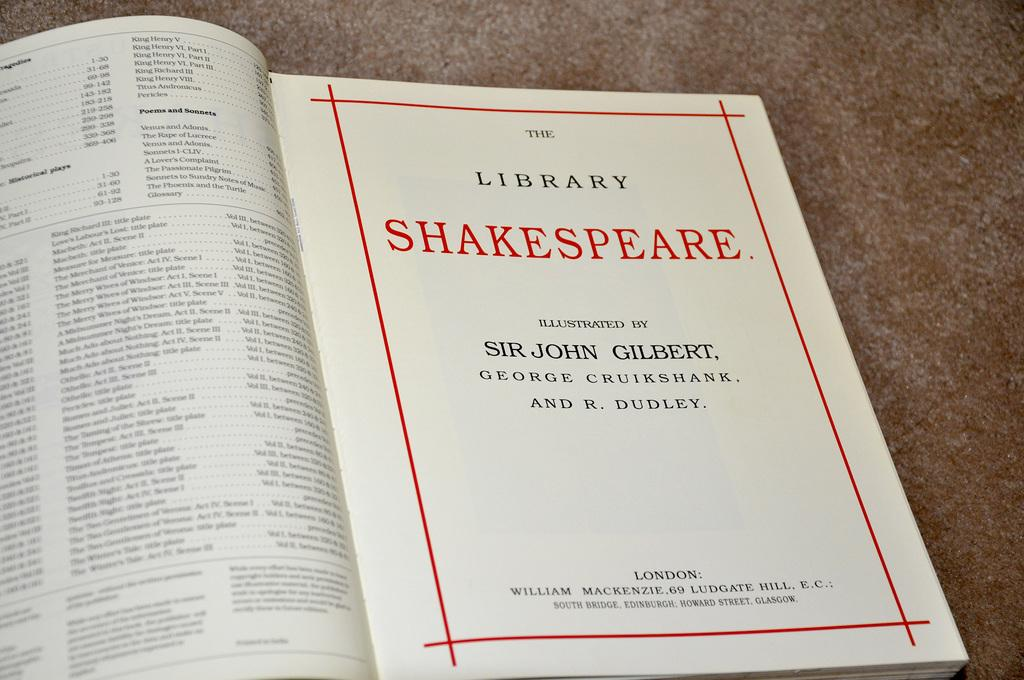<image>
Share a concise interpretation of the image provided. A book or pamphlet of the library shakespeare. 